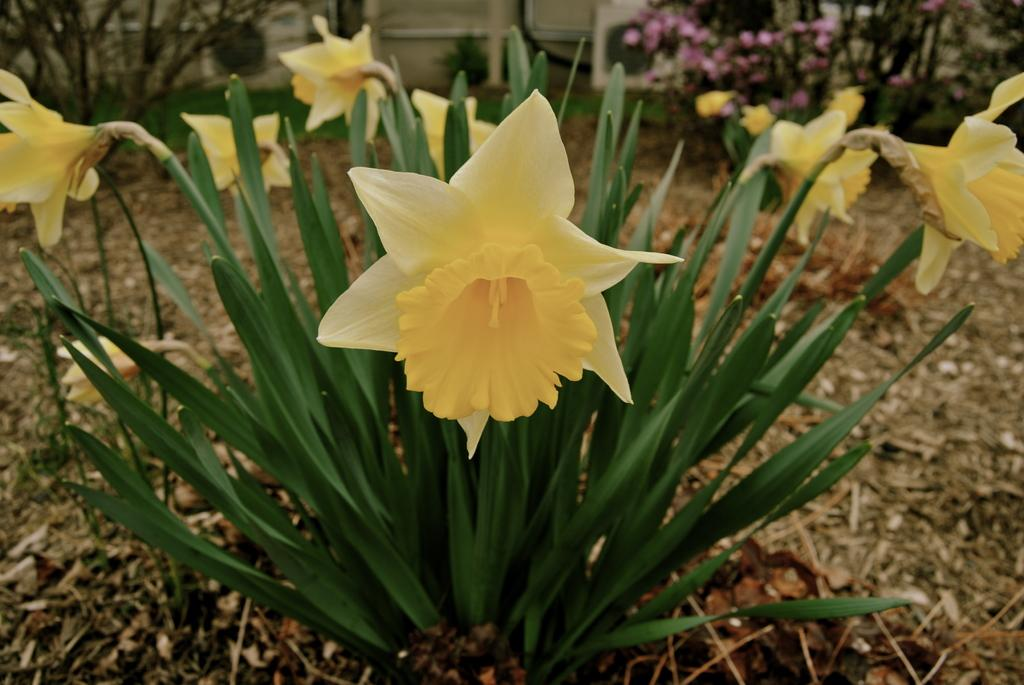What type of living organisms can be seen in the image? Plants can be seen in the image. What specific feature of the plants is visible in the image? The plants have flowers. What type of marble is visible on the hat worn by the plant in the image? There is no hat or marble present in the image; it features plants with flowers. 